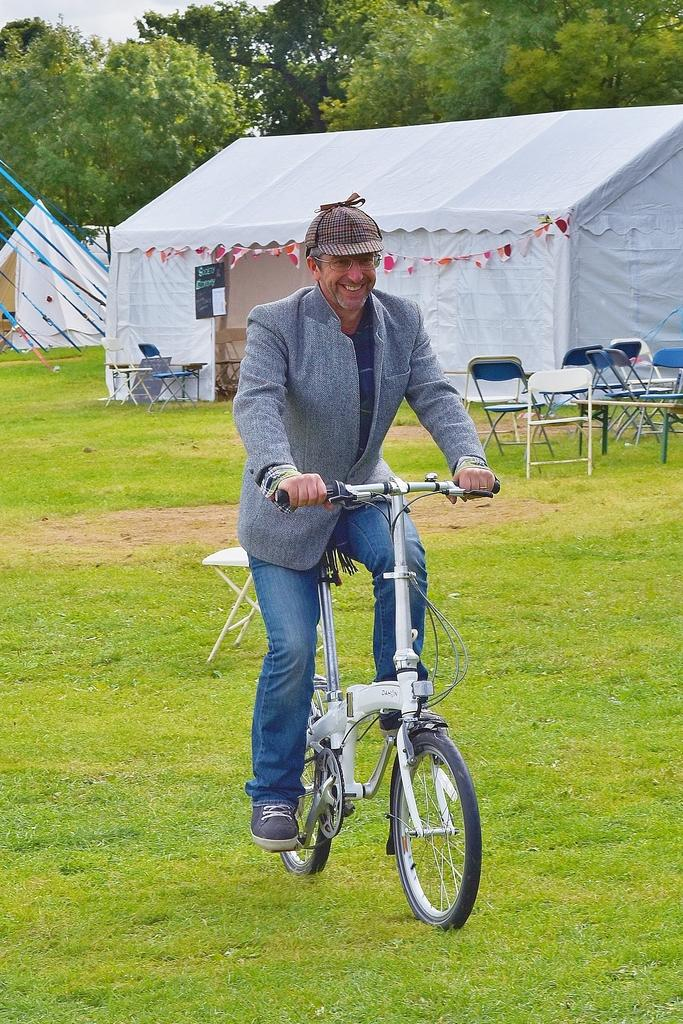What is the person in the image doing? There is a person sitting on a bicycle in the image. What structure is visible behind the person? There is a tent behind the person. What type of furniture is in front of the tent? There are chairs in front of the tent. What is visible at the top of the image? The sky is visible at the top of the image. What type of vegetation is present in the image? Trees are present in the image. Can you see any rifles in the image? There are no rifles present in the image. Is the image set during the night? The image does not provide any information about the time of day, but it does not appear to be night based on the visibility of the sky and trees. 